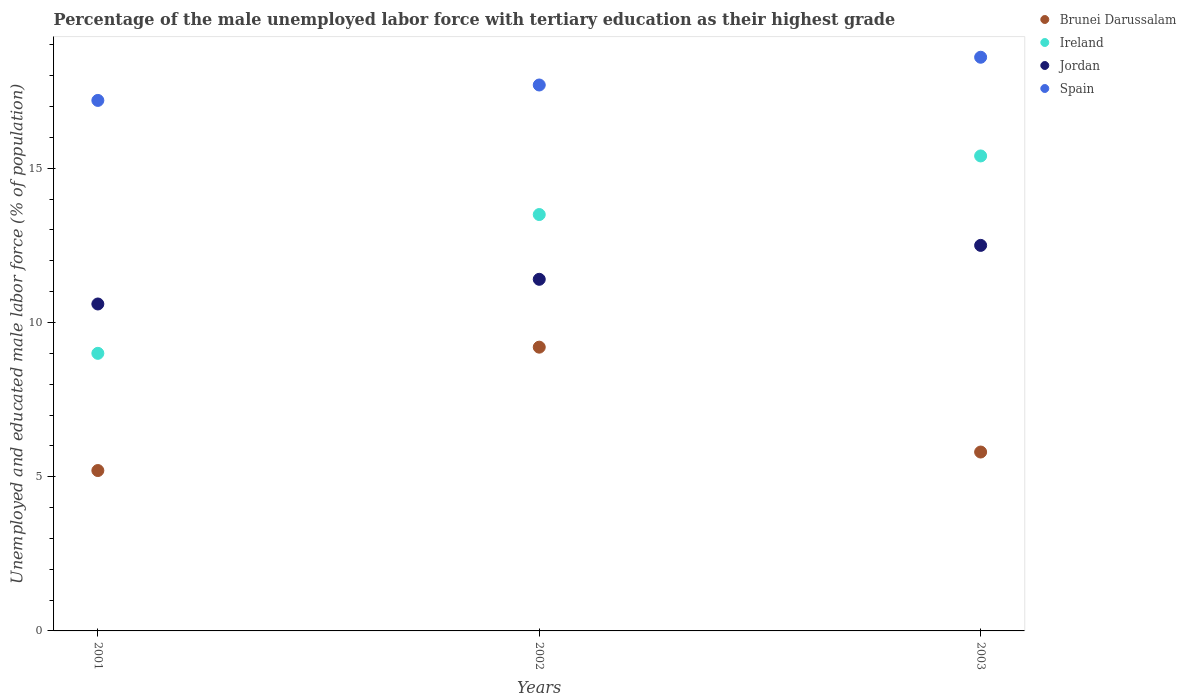Is the number of dotlines equal to the number of legend labels?
Provide a succinct answer. Yes. What is the percentage of the unemployed male labor force with tertiary education in Ireland in 2001?
Provide a short and direct response. 9. Across all years, what is the maximum percentage of the unemployed male labor force with tertiary education in Spain?
Your answer should be very brief. 18.6. Across all years, what is the minimum percentage of the unemployed male labor force with tertiary education in Spain?
Offer a very short reply. 17.2. What is the total percentage of the unemployed male labor force with tertiary education in Spain in the graph?
Ensure brevity in your answer.  53.5. What is the difference between the percentage of the unemployed male labor force with tertiary education in Ireland in 2001 and that in 2003?
Keep it short and to the point. -6.4. What is the difference between the percentage of the unemployed male labor force with tertiary education in Jordan in 2002 and the percentage of the unemployed male labor force with tertiary education in Spain in 2001?
Ensure brevity in your answer.  -5.8. What is the average percentage of the unemployed male labor force with tertiary education in Brunei Darussalam per year?
Ensure brevity in your answer.  6.73. In the year 2001, what is the difference between the percentage of the unemployed male labor force with tertiary education in Jordan and percentage of the unemployed male labor force with tertiary education in Brunei Darussalam?
Keep it short and to the point. 5.4. In how many years, is the percentage of the unemployed male labor force with tertiary education in Jordan greater than 11 %?
Offer a very short reply. 2. What is the ratio of the percentage of the unemployed male labor force with tertiary education in Spain in 2001 to that in 2002?
Give a very brief answer. 0.97. Is the difference between the percentage of the unemployed male labor force with tertiary education in Jordan in 2002 and 2003 greater than the difference between the percentage of the unemployed male labor force with tertiary education in Brunei Darussalam in 2002 and 2003?
Keep it short and to the point. No. What is the difference between the highest and the second highest percentage of the unemployed male labor force with tertiary education in Spain?
Ensure brevity in your answer.  0.9. What is the difference between the highest and the lowest percentage of the unemployed male labor force with tertiary education in Jordan?
Provide a succinct answer. 1.9. In how many years, is the percentage of the unemployed male labor force with tertiary education in Jordan greater than the average percentage of the unemployed male labor force with tertiary education in Jordan taken over all years?
Keep it short and to the point. 1. Is it the case that in every year, the sum of the percentage of the unemployed male labor force with tertiary education in Brunei Darussalam and percentage of the unemployed male labor force with tertiary education in Ireland  is greater than the sum of percentage of the unemployed male labor force with tertiary education in Jordan and percentage of the unemployed male labor force with tertiary education in Spain?
Keep it short and to the point. No. Does the percentage of the unemployed male labor force with tertiary education in Jordan monotonically increase over the years?
Provide a short and direct response. Yes. Is the percentage of the unemployed male labor force with tertiary education in Brunei Darussalam strictly greater than the percentage of the unemployed male labor force with tertiary education in Ireland over the years?
Ensure brevity in your answer.  No. What is the difference between two consecutive major ticks on the Y-axis?
Your response must be concise. 5. Are the values on the major ticks of Y-axis written in scientific E-notation?
Give a very brief answer. No. Does the graph contain any zero values?
Make the answer very short. No. Where does the legend appear in the graph?
Ensure brevity in your answer.  Top right. How are the legend labels stacked?
Your answer should be very brief. Vertical. What is the title of the graph?
Offer a very short reply. Percentage of the male unemployed labor force with tertiary education as their highest grade. Does "Suriname" appear as one of the legend labels in the graph?
Ensure brevity in your answer.  No. What is the label or title of the X-axis?
Offer a terse response. Years. What is the label or title of the Y-axis?
Ensure brevity in your answer.  Unemployed and educated male labor force (% of population). What is the Unemployed and educated male labor force (% of population) in Brunei Darussalam in 2001?
Offer a terse response. 5.2. What is the Unemployed and educated male labor force (% of population) in Ireland in 2001?
Your response must be concise. 9. What is the Unemployed and educated male labor force (% of population) in Jordan in 2001?
Your answer should be very brief. 10.6. What is the Unemployed and educated male labor force (% of population) of Spain in 2001?
Offer a very short reply. 17.2. What is the Unemployed and educated male labor force (% of population) in Brunei Darussalam in 2002?
Provide a short and direct response. 9.2. What is the Unemployed and educated male labor force (% of population) of Ireland in 2002?
Your answer should be compact. 13.5. What is the Unemployed and educated male labor force (% of population) in Jordan in 2002?
Your answer should be compact. 11.4. What is the Unemployed and educated male labor force (% of population) of Spain in 2002?
Provide a succinct answer. 17.7. What is the Unemployed and educated male labor force (% of population) of Brunei Darussalam in 2003?
Offer a terse response. 5.8. What is the Unemployed and educated male labor force (% of population) of Ireland in 2003?
Offer a very short reply. 15.4. What is the Unemployed and educated male labor force (% of population) in Spain in 2003?
Your response must be concise. 18.6. Across all years, what is the maximum Unemployed and educated male labor force (% of population) in Brunei Darussalam?
Your answer should be compact. 9.2. Across all years, what is the maximum Unemployed and educated male labor force (% of population) in Ireland?
Offer a very short reply. 15.4. Across all years, what is the maximum Unemployed and educated male labor force (% of population) of Jordan?
Your answer should be compact. 12.5. Across all years, what is the maximum Unemployed and educated male labor force (% of population) in Spain?
Ensure brevity in your answer.  18.6. Across all years, what is the minimum Unemployed and educated male labor force (% of population) in Brunei Darussalam?
Make the answer very short. 5.2. Across all years, what is the minimum Unemployed and educated male labor force (% of population) of Ireland?
Keep it short and to the point. 9. Across all years, what is the minimum Unemployed and educated male labor force (% of population) in Jordan?
Provide a succinct answer. 10.6. Across all years, what is the minimum Unemployed and educated male labor force (% of population) of Spain?
Make the answer very short. 17.2. What is the total Unemployed and educated male labor force (% of population) of Brunei Darussalam in the graph?
Your answer should be compact. 20.2. What is the total Unemployed and educated male labor force (% of population) of Ireland in the graph?
Ensure brevity in your answer.  37.9. What is the total Unemployed and educated male labor force (% of population) of Jordan in the graph?
Your answer should be very brief. 34.5. What is the total Unemployed and educated male labor force (% of population) in Spain in the graph?
Provide a succinct answer. 53.5. What is the difference between the Unemployed and educated male labor force (% of population) of Brunei Darussalam in 2001 and that in 2002?
Ensure brevity in your answer.  -4. What is the difference between the Unemployed and educated male labor force (% of population) of Ireland in 2001 and that in 2002?
Your response must be concise. -4.5. What is the difference between the Unemployed and educated male labor force (% of population) of Brunei Darussalam in 2001 and that in 2003?
Make the answer very short. -0.6. What is the difference between the Unemployed and educated male labor force (% of population) in Jordan in 2001 and that in 2003?
Your response must be concise. -1.9. What is the difference between the Unemployed and educated male labor force (% of population) in Spain in 2001 and that in 2003?
Offer a very short reply. -1.4. What is the difference between the Unemployed and educated male labor force (% of population) in Brunei Darussalam in 2002 and that in 2003?
Your response must be concise. 3.4. What is the difference between the Unemployed and educated male labor force (% of population) in Ireland in 2002 and that in 2003?
Offer a very short reply. -1.9. What is the difference between the Unemployed and educated male labor force (% of population) of Jordan in 2002 and that in 2003?
Keep it short and to the point. -1.1. What is the difference between the Unemployed and educated male labor force (% of population) of Brunei Darussalam in 2001 and the Unemployed and educated male labor force (% of population) of Jordan in 2002?
Provide a succinct answer. -6.2. What is the difference between the Unemployed and educated male labor force (% of population) in Ireland in 2001 and the Unemployed and educated male labor force (% of population) in Jordan in 2002?
Your answer should be very brief. -2.4. What is the difference between the Unemployed and educated male labor force (% of population) of Jordan in 2001 and the Unemployed and educated male labor force (% of population) of Spain in 2002?
Give a very brief answer. -7.1. What is the difference between the Unemployed and educated male labor force (% of population) in Brunei Darussalam in 2001 and the Unemployed and educated male labor force (% of population) in Jordan in 2003?
Ensure brevity in your answer.  -7.3. What is the difference between the Unemployed and educated male labor force (% of population) of Ireland in 2001 and the Unemployed and educated male labor force (% of population) of Spain in 2003?
Offer a terse response. -9.6. What is the difference between the Unemployed and educated male labor force (% of population) in Brunei Darussalam in 2002 and the Unemployed and educated male labor force (% of population) in Jordan in 2003?
Provide a short and direct response. -3.3. What is the difference between the Unemployed and educated male labor force (% of population) of Brunei Darussalam in 2002 and the Unemployed and educated male labor force (% of population) of Spain in 2003?
Offer a very short reply. -9.4. What is the difference between the Unemployed and educated male labor force (% of population) of Ireland in 2002 and the Unemployed and educated male labor force (% of population) of Spain in 2003?
Ensure brevity in your answer.  -5.1. What is the difference between the Unemployed and educated male labor force (% of population) in Jordan in 2002 and the Unemployed and educated male labor force (% of population) in Spain in 2003?
Your answer should be compact. -7.2. What is the average Unemployed and educated male labor force (% of population) in Brunei Darussalam per year?
Offer a terse response. 6.73. What is the average Unemployed and educated male labor force (% of population) in Ireland per year?
Keep it short and to the point. 12.63. What is the average Unemployed and educated male labor force (% of population) in Spain per year?
Your response must be concise. 17.83. In the year 2001, what is the difference between the Unemployed and educated male labor force (% of population) in Ireland and Unemployed and educated male labor force (% of population) in Jordan?
Your response must be concise. -1.6. In the year 2001, what is the difference between the Unemployed and educated male labor force (% of population) in Ireland and Unemployed and educated male labor force (% of population) in Spain?
Your response must be concise. -8.2. In the year 2002, what is the difference between the Unemployed and educated male labor force (% of population) of Brunei Darussalam and Unemployed and educated male labor force (% of population) of Ireland?
Provide a short and direct response. -4.3. In the year 2002, what is the difference between the Unemployed and educated male labor force (% of population) of Ireland and Unemployed and educated male labor force (% of population) of Jordan?
Make the answer very short. 2.1. In the year 2002, what is the difference between the Unemployed and educated male labor force (% of population) in Jordan and Unemployed and educated male labor force (% of population) in Spain?
Offer a terse response. -6.3. In the year 2003, what is the difference between the Unemployed and educated male labor force (% of population) in Brunei Darussalam and Unemployed and educated male labor force (% of population) in Ireland?
Your answer should be compact. -9.6. In the year 2003, what is the difference between the Unemployed and educated male labor force (% of population) in Ireland and Unemployed and educated male labor force (% of population) in Jordan?
Make the answer very short. 2.9. In the year 2003, what is the difference between the Unemployed and educated male labor force (% of population) in Ireland and Unemployed and educated male labor force (% of population) in Spain?
Offer a terse response. -3.2. In the year 2003, what is the difference between the Unemployed and educated male labor force (% of population) of Jordan and Unemployed and educated male labor force (% of population) of Spain?
Provide a short and direct response. -6.1. What is the ratio of the Unemployed and educated male labor force (% of population) in Brunei Darussalam in 2001 to that in 2002?
Provide a succinct answer. 0.57. What is the ratio of the Unemployed and educated male labor force (% of population) of Jordan in 2001 to that in 2002?
Offer a very short reply. 0.93. What is the ratio of the Unemployed and educated male labor force (% of population) of Spain in 2001 to that in 2002?
Ensure brevity in your answer.  0.97. What is the ratio of the Unemployed and educated male labor force (% of population) of Brunei Darussalam in 2001 to that in 2003?
Keep it short and to the point. 0.9. What is the ratio of the Unemployed and educated male labor force (% of population) in Ireland in 2001 to that in 2003?
Give a very brief answer. 0.58. What is the ratio of the Unemployed and educated male labor force (% of population) of Jordan in 2001 to that in 2003?
Your answer should be very brief. 0.85. What is the ratio of the Unemployed and educated male labor force (% of population) in Spain in 2001 to that in 2003?
Provide a short and direct response. 0.92. What is the ratio of the Unemployed and educated male labor force (% of population) in Brunei Darussalam in 2002 to that in 2003?
Your answer should be very brief. 1.59. What is the ratio of the Unemployed and educated male labor force (% of population) in Ireland in 2002 to that in 2003?
Provide a succinct answer. 0.88. What is the ratio of the Unemployed and educated male labor force (% of population) in Jordan in 2002 to that in 2003?
Make the answer very short. 0.91. What is the ratio of the Unemployed and educated male labor force (% of population) of Spain in 2002 to that in 2003?
Offer a terse response. 0.95. What is the difference between the highest and the second highest Unemployed and educated male labor force (% of population) in Brunei Darussalam?
Keep it short and to the point. 3.4. What is the difference between the highest and the second highest Unemployed and educated male labor force (% of population) in Ireland?
Make the answer very short. 1.9. What is the difference between the highest and the second highest Unemployed and educated male labor force (% of population) in Jordan?
Your response must be concise. 1.1. What is the difference between the highest and the lowest Unemployed and educated male labor force (% of population) in Brunei Darussalam?
Ensure brevity in your answer.  4. What is the difference between the highest and the lowest Unemployed and educated male labor force (% of population) in Ireland?
Your answer should be compact. 6.4. What is the difference between the highest and the lowest Unemployed and educated male labor force (% of population) in Jordan?
Keep it short and to the point. 1.9. What is the difference between the highest and the lowest Unemployed and educated male labor force (% of population) of Spain?
Offer a very short reply. 1.4. 